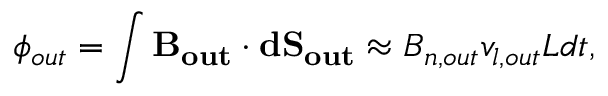<formula> <loc_0><loc_0><loc_500><loc_500>\phi _ { o u t } = \int B _ { o u t } \cdot d S _ { o u t } \approx B _ { n , o u t } v _ { l , o u t } L d t ,</formula> 